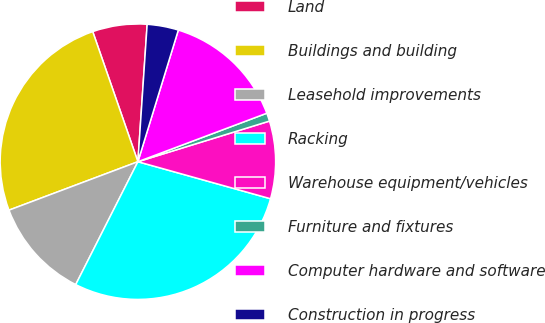Convert chart to OTSL. <chart><loc_0><loc_0><loc_500><loc_500><pie_chart><fcel>Land<fcel>Buildings and building<fcel>Leasehold improvements<fcel>Racking<fcel>Warehouse equipment/vehicles<fcel>Furniture and fixtures<fcel>Computer hardware and software<fcel>Construction in progress<nl><fcel>6.39%<fcel>25.4%<fcel>11.82%<fcel>28.12%<fcel>9.1%<fcel>0.96%<fcel>14.53%<fcel>3.67%<nl></chart> 